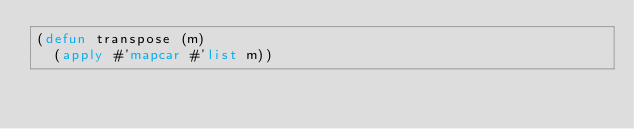<code> <loc_0><loc_0><loc_500><loc_500><_Lisp_>(defun transpose (m)
  (apply #'mapcar #'list m))
</code> 